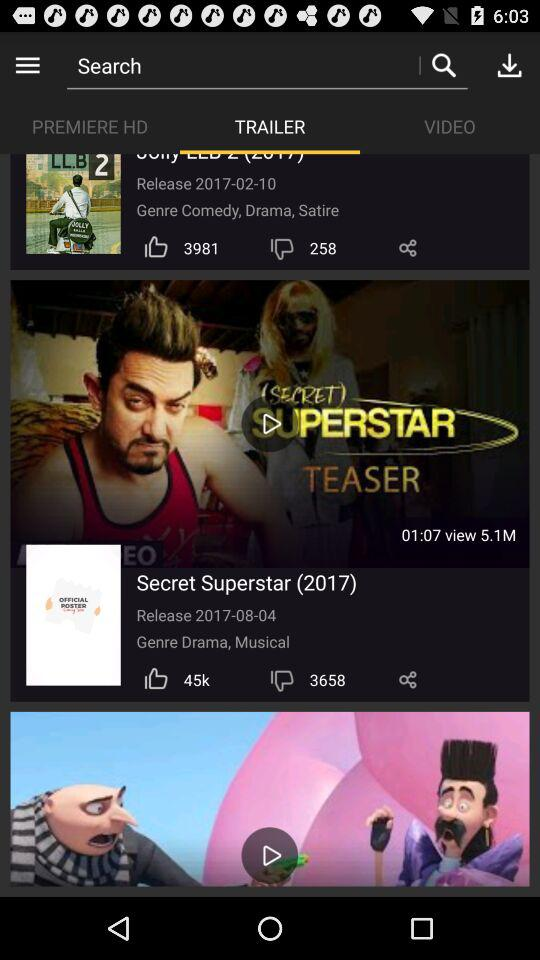What tab are we on? The tab is "TRAILER". 